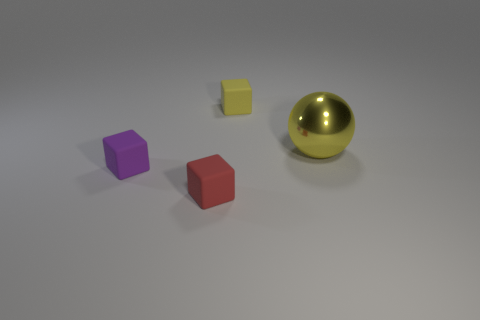Is there a red rubber object that is to the right of the thing that is on the right side of the yellow rubber cube?
Offer a very short reply. No. What number of other things are the same color as the shiny ball?
Your answer should be compact. 1. The yellow metallic sphere has what size?
Provide a succinct answer. Large. Are any large green metal cubes visible?
Your answer should be compact. No. Is the number of large shiny objects behind the big yellow object greater than the number of purple cubes that are on the right side of the purple rubber block?
Your answer should be very brief. No. What material is the small cube that is on the left side of the yellow cube and behind the tiny red matte cube?
Your answer should be compact. Rubber. Do the tiny red thing and the yellow matte object have the same shape?
Your answer should be very brief. Yes. Is there anything else that is the same size as the purple rubber cube?
Offer a very short reply. Yes. There is a metallic ball; what number of tiny objects are in front of it?
Ensure brevity in your answer.  2. There is a block behind the shiny sphere; is it the same size as the large yellow sphere?
Your answer should be very brief. No. 